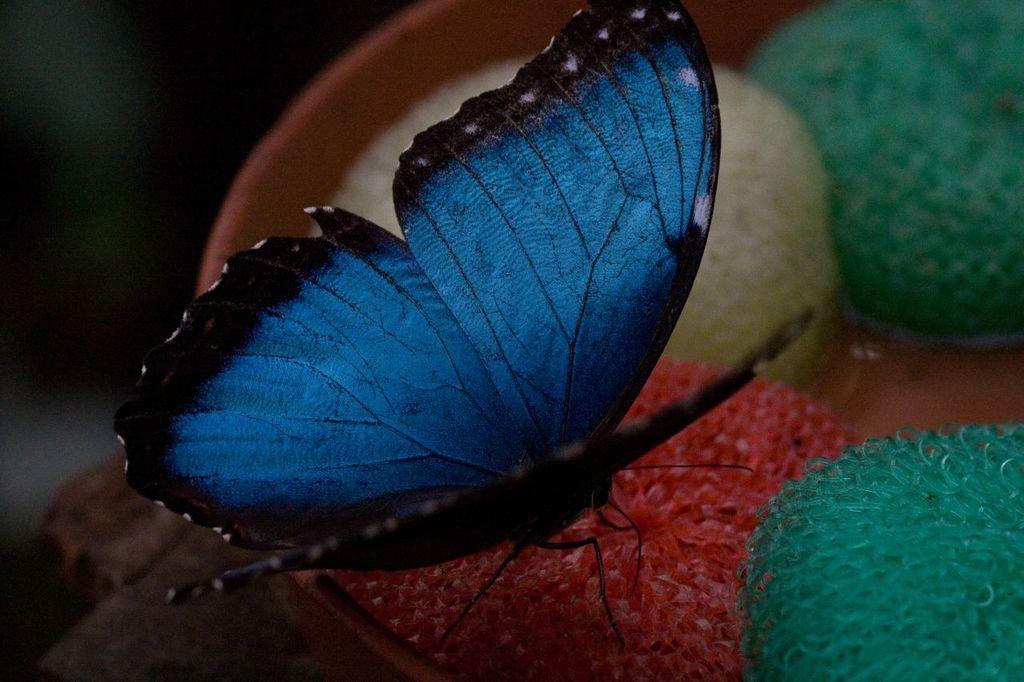Describe this image in one or two sentences. In this image we can see a butterfly on the surface. 